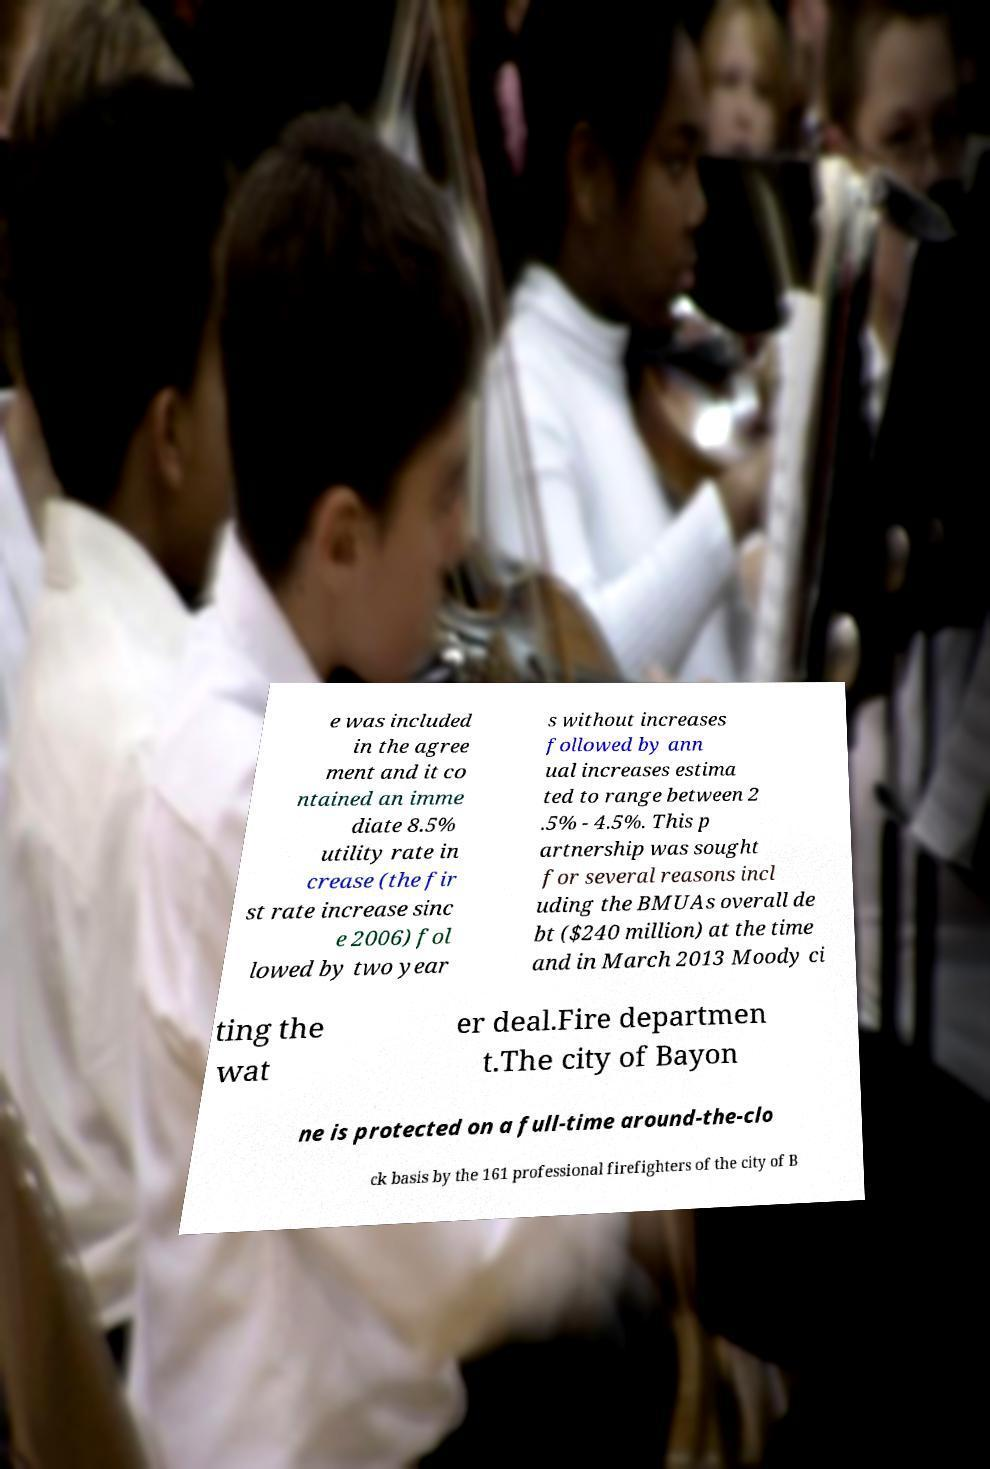What messages or text are displayed in this image? I need them in a readable, typed format. e was included in the agree ment and it co ntained an imme diate 8.5% utility rate in crease (the fir st rate increase sinc e 2006) fol lowed by two year s without increases followed by ann ual increases estima ted to range between 2 .5% - 4.5%. This p artnership was sought for several reasons incl uding the BMUAs overall de bt ($240 million) at the time and in March 2013 Moody ci ting the wat er deal.Fire departmen t.The city of Bayon ne is protected on a full-time around-the-clo ck basis by the 161 professional firefighters of the city of B 